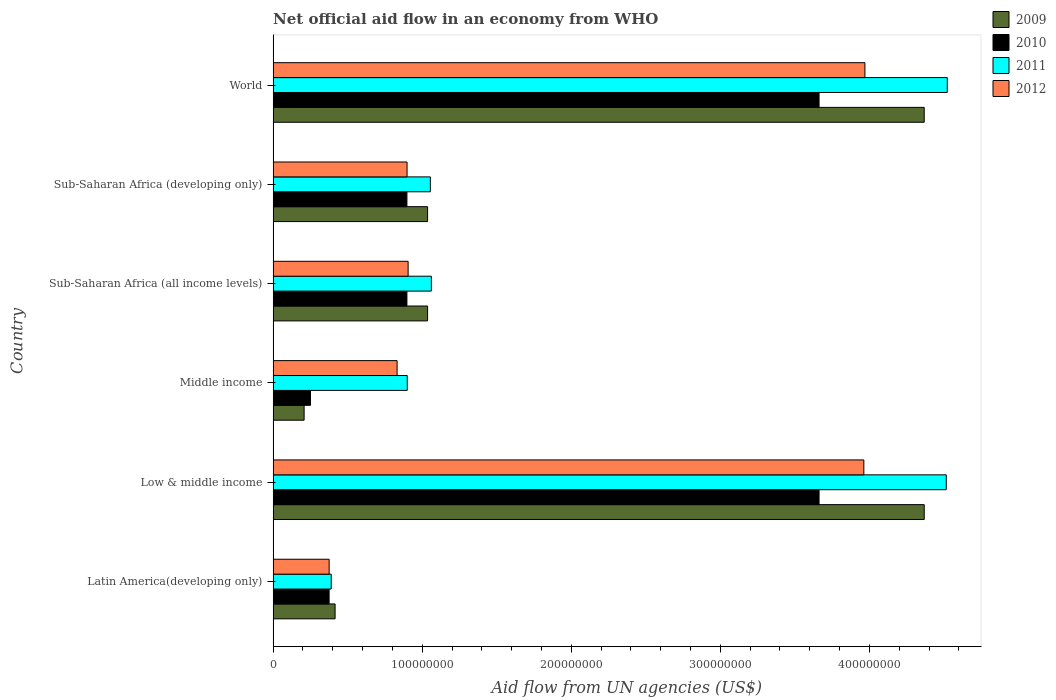How many different coloured bars are there?
Provide a succinct answer. 4. How many groups of bars are there?
Give a very brief answer. 6. Are the number of bars per tick equal to the number of legend labels?
Your answer should be very brief. Yes. How many bars are there on the 1st tick from the bottom?
Make the answer very short. 4. What is the label of the 1st group of bars from the top?
Provide a short and direct response. World. What is the net official aid flow in 2012 in Sub-Saharan Africa (developing only)?
Provide a short and direct response. 8.98e+07. Across all countries, what is the maximum net official aid flow in 2012?
Keep it short and to the point. 3.97e+08. Across all countries, what is the minimum net official aid flow in 2009?
Offer a terse response. 2.08e+07. What is the total net official aid flow in 2009 in the graph?
Your answer should be very brief. 1.14e+09. What is the difference between the net official aid flow in 2012 in Latin America(developing only) and that in Low & middle income?
Your answer should be very brief. -3.59e+08. What is the difference between the net official aid flow in 2011 in Sub-Saharan Africa (all income levels) and the net official aid flow in 2009 in Middle income?
Give a very brief answer. 8.54e+07. What is the average net official aid flow in 2009 per country?
Give a very brief answer. 1.91e+08. What is the difference between the net official aid flow in 2012 and net official aid flow in 2009 in Middle income?
Your answer should be very brief. 6.24e+07. In how many countries, is the net official aid flow in 2011 greater than 300000000 US$?
Offer a terse response. 2. What is the ratio of the net official aid flow in 2009 in Low & middle income to that in Sub-Saharan Africa (developing only)?
Your answer should be compact. 4.22. What is the difference between the highest and the second highest net official aid flow in 2011?
Your response must be concise. 6.70e+05. What is the difference between the highest and the lowest net official aid flow in 2010?
Make the answer very short. 3.41e+08. In how many countries, is the net official aid flow in 2012 greater than the average net official aid flow in 2012 taken over all countries?
Provide a succinct answer. 2. Is the sum of the net official aid flow in 2010 in Low & middle income and Sub-Saharan Africa (all income levels) greater than the maximum net official aid flow in 2012 across all countries?
Provide a short and direct response. Yes. Is it the case that in every country, the sum of the net official aid flow in 2010 and net official aid flow in 2009 is greater than the sum of net official aid flow in 2012 and net official aid flow in 2011?
Your answer should be very brief. No. What does the 4th bar from the top in Middle income represents?
Keep it short and to the point. 2009. Is it the case that in every country, the sum of the net official aid flow in 2010 and net official aid flow in 2009 is greater than the net official aid flow in 2012?
Your answer should be compact. No. How many bars are there?
Your answer should be compact. 24. Are all the bars in the graph horizontal?
Provide a short and direct response. Yes. What is the difference between two consecutive major ticks on the X-axis?
Your answer should be very brief. 1.00e+08. Are the values on the major ticks of X-axis written in scientific E-notation?
Offer a terse response. No. Does the graph contain grids?
Your answer should be very brief. No. What is the title of the graph?
Offer a very short reply. Net official aid flow in an economy from WHO. Does "1975" appear as one of the legend labels in the graph?
Offer a very short reply. No. What is the label or title of the X-axis?
Your response must be concise. Aid flow from UN agencies (US$). What is the label or title of the Y-axis?
Provide a short and direct response. Country. What is the Aid flow from UN agencies (US$) in 2009 in Latin America(developing only)?
Your response must be concise. 4.16e+07. What is the Aid flow from UN agencies (US$) of 2010 in Latin America(developing only)?
Provide a short and direct response. 3.76e+07. What is the Aid flow from UN agencies (US$) in 2011 in Latin America(developing only)?
Make the answer very short. 3.90e+07. What is the Aid flow from UN agencies (US$) in 2012 in Latin America(developing only)?
Provide a succinct answer. 3.76e+07. What is the Aid flow from UN agencies (US$) in 2009 in Low & middle income?
Make the answer very short. 4.37e+08. What is the Aid flow from UN agencies (US$) in 2010 in Low & middle income?
Your answer should be compact. 3.66e+08. What is the Aid flow from UN agencies (US$) of 2011 in Low & middle income?
Ensure brevity in your answer.  4.52e+08. What is the Aid flow from UN agencies (US$) in 2012 in Low & middle income?
Your answer should be very brief. 3.96e+08. What is the Aid flow from UN agencies (US$) in 2009 in Middle income?
Give a very brief answer. 2.08e+07. What is the Aid flow from UN agencies (US$) of 2010 in Middle income?
Offer a very short reply. 2.51e+07. What is the Aid flow from UN agencies (US$) of 2011 in Middle income?
Your answer should be compact. 9.00e+07. What is the Aid flow from UN agencies (US$) in 2012 in Middle income?
Provide a short and direct response. 8.32e+07. What is the Aid flow from UN agencies (US$) in 2009 in Sub-Saharan Africa (all income levels)?
Offer a terse response. 1.04e+08. What is the Aid flow from UN agencies (US$) of 2010 in Sub-Saharan Africa (all income levels)?
Offer a very short reply. 8.98e+07. What is the Aid flow from UN agencies (US$) in 2011 in Sub-Saharan Africa (all income levels)?
Ensure brevity in your answer.  1.06e+08. What is the Aid flow from UN agencies (US$) in 2012 in Sub-Saharan Africa (all income levels)?
Provide a short and direct response. 9.06e+07. What is the Aid flow from UN agencies (US$) of 2009 in Sub-Saharan Africa (developing only)?
Make the answer very short. 1.04e+08. What is the Aid flow from UN agencies (US$) in 2010 in Sub-Saharan Africa (developing only)?
Give a very brief answer. 8.98e+07. What is the Aid flow from UN agencies (US$) in 2011 in Sub-Saharan Africa (developing only)?
Keep it short and to the point. 1.05e+08. What is the Aid flow from UN agencies (US$) of 2012 in Sub-Saharan Africa (developing only)?
Offer a terse response. 8.98e+07. What is the Aid flow from UN agencies (US$) of 2009 in World?
Your response must be concise. 4.37e+08. What is the Aid flow from UN agencies (US$) in 2010 in World?
Your answer should be very brief. 3.66e+08. What is the Aid flow from UN agencies (US$) of 2011 in World?
Your response must be concise. 4.52e+08. What is the Aid flow from UN agencies (US$) in 2012 in World?
Keep it short and to the point. 3.97e+08. Across all countries, what is the maximum Aid flow from UN agencies (US$) of 2009?
Make the answer very short. 4.37e+08. Across all countries, what is the maximum Aid flow from UN agencies (US$) in 2010?
Make the answer very short. 3.66e+08. Across all countries, what is the maximum Aid flow from UN agencies (US$) of 2011?
Make the answer very short. 4.52e+08. Across all countries, what is the maximum Aid flow from UN agencies (US$) of 2012?
Offer a terse response. 3.97e+08. Across all countries, what is the minimum Aid flow from UN agencies (US$) in 2009?
Offer a very short reply. 2.08e+07. Across all countries, what is the minimum Aid flow from UN agencies (US$) in 2010?
Provide a short and direct response. 2.51e+07. Across all countries, what is the minimum Aid flow from UN agencies (US$) in 2011?
Offer a terse response. 3.90e+07. Across all countries, what is the minimum Aid flow from UN agencies (US$) of 2012?
Make the answer very short. 3.76e+07. What is the total Aid flow from UN agencies (US$) in 2009 in the graph?
Keep it short and to the point. 1.14e+09. What is the total Aid flow from UN agencies (US$) in 2010 in the graph?
Provide a short and direct response. 9.75e+08. What is the total Aid flow from UN agencies (US$) in 2011 in the graph?
Offer a terse response. 1.24e+09. What is the total Aid flow from UN agencies (US$) of 2012 in the graph?
Your response must be concise. 1.09e+09. What is the difference between the Aid flow from UN agencies (US$) of 2009 in Latin America(developing only) and that in Low & middle income?
Your answer should be compact. -3.95e+08. What is the difference between the Aid flow from UN agencies (US$) in 2010 in Latin America(developing only) and that in Low & middle income?
Provide a short and direct response. -3.29e+08. What is the difference between the Aid flow from UN agencies (US$) of 2011 in Latin America(developing only) and that in Low & middle income?
Provide a succinct answer. -4.13e+08. What is the difference between the Aid flow from UN agencies (US$) of 2012 in Latin America(developing only) and that in Low & middle income?
Your answer should be compact. -3.59e+08. What is the difference between the Aid flow from UN agencies (US$) of 2009 in Latin America(developing only) and that in Middle income?
Provide a short and direct response. 2.08e+07. What is the difference between the Aid flow from UN agencies (US$) in 2010 in Latin America(developing only) and that in Middle income?
Give a very brief answer. 1.25e+07. What is the difference between the Aid flow from UN agencies (US$) in 2011 in Latin America(developing only) and that in Middle income?
Give a very brief answer. -5.10e+07. What is the difference between the Aid flow from UN agencies (US$) of 2012 in Latin America(developing only) and that in Middle income?
Keep it short and to the point. -4.56e+07. What is the difference between the Aid flow from UN agencies (US$) of 2009 in Latin America(developing only) and that in Sub-Saharan Africa (all income levels)?
Your answer should be very brief. -6.20e+07. What is the difference between the Aid flow from UN agencies (US$) in 2010 in Latin America(developing only) and that in Sub-Saharan Africa (all income levels)?
Provide a succinct answer. -5.22e+07. What is the difference between the Aid flow from UN agencies (US$) in 2011 in Latin America(developing only) and that in Sub-Saharan Africa (all income levels)?
Offer a very short reply. -6.72e+07. What is the difference between the Aid flow from UN agencies (US$) of 2012 in Latin America(developing only) and that in Sub-Saharan Africa (all income levels)?
Ensure brevity in your answer.  -5.30e+07. What is the difference between the Aid flow from UN agencies (US$) of 2009 in Latin America(developing only) and that in Sub-Saharan Africa (developing only)?
Your response must be concise. -6.20e+07. What is the difference between the Aid flow from UN agencies (US$) in 2010 in Latin America(developing only) and that in Sub-Saharan Africa (developing only)?
Provide a short and direct response. -5.22e+07. What is the difference between the Aid flow from UN agencies (US$) of 2011 in Latin America(developing only) and that in Sub-Saharan Africa (developing only)?
Provide a short and direct response. -6.65e+07. What is the difference between the Aid flow from UN agencies (US$) in 2012 in Latin America(developing only) and that in Sub-Saharan Africa (developing only)?
Keep it short and to the point. -5.23e+07. What is the difference between the Aid flow from UN agencies (US$) in 2009 in Latin America(developing only) and that in World?
Keep it short and to the point. -3.95e+08. What is the difference between the Aid flow from UN agencies (US$) of 2010 in Latin America(developing only) and that in World?
Your answer should be very brief. -3.29e+08. What is the difference between the Aid flow from UN agencies (US$) in 2011 in Latin America(developing only) and that in World?
Offer a terse response. -4.13e+08. What is the difference between the Aid flow from UN agencies (US$) of 2012 in Latin America(developing only) and that in World?
Keep it short and to the point. -3.59e+08. What is the difference between the Aid flow from UN agencies (US$) of 2009 in Low & middle income and that in Middle income?
Make the answer very short. 4.16e+08. What is the difference between the Aid flow from UN agencies (US$) of 2010 in Low & middle income and that in Middle income?
Provide a succinct answer. 3.41e+08. What is the difference between the Aid flow from UN agencies (US$) in 2011 in Low & middle income and that in Middle income?
Offer a terse response. 3.62e+08. What is the difference between the Aid flow from UN agencies (US$) of 2012 in Low & middle income and that in Middle income?
Your response must be concise. 3.13e+08. What is the difference between the Aid flow from UN agencies (US$) of 2009 in Low & middle income and that in Sub-Saharan Africa (all income levels)?
Give a very brief answer. 3.33e+08. What is the difference between the Aid flow from UN agencies (US$) of 2010 in Low & middle income and that in Sub-Saharan Africa (all income levels)?
Offer a terse response. 2.76e+08. What is the difference between the Aid flow from UN agencies (US$) in 2011 in Low & middle income and that in Sub-Saharan Africa (all income levels)?
Keep it short and to the point. 3.45e+08. What is the difference between the Aid flow from UN agencies (US$) of 2012 in Low & middle income and that in Sub-Saharan Africa (all income levels)?
Your response must be concise. 3.06e+08. What is the difference between the Aid flow from UN agencies (US$) in 2009 in Low & middle income and that in Sub-Saharan Africa (developing only)?
Your answer should be compact. 3.33e+08. What is the difference between the Aid flow from UN agencies (US$) of 2010 in Low & middle income and that in Sub-Saharan Africa (developing only)?
Provide a short and direct response. 2.76e+08. What is the difference between the Aid flow from UN agencies (US$) in 2011 in Low & middle income and that in Sub-Saharan Africa (developing only)?
Offer a very short reply. 3.46e+08. What is the difference between the Aid flow from UN agencies (US$) of 2012 in Low & middle income and that in Sub-Saharan Africa (developing only)?
Make the answer very short. 3.06e+08. What is the difference between the Aid flow from UN agencies (US$) in 2009 in Low & middle income and that in World?
Offer a very short reply. 0. What is the difference between the Aid flow from UN agencies (US$) in 2010 in Low & middle income and that in World?
Keep it short and to the point. 0. What is the difference between the Aid flow from UN agencies (US$) in 2011 in Low & middle income and that in World?
Ensure brevity in your answer.  -6.70e+05. What is the difference between the Aid flow from UN agencies (US$) in 2012 in Low & middle income and that in World?
Your answer should be compact. -7.20e+05. What is the difference between the Aid flow from UN agencies (US$) of 2009 in Middle income and that in Sub-Saharan Africa (all income levels)?
Keep it short and to the point. -8.28e+07. What is the difference between the Aid flow from UN agencies (US$) in 2010 in Middle income and that in Sub-Saharan Africa (all income levels)?
Make the answer very short. -6.47e+07. What is the difference between the Aid flow from UN agencies (US$) in 2011 in Middle income and that in Sub-Saharan Africa (all income levels)?
Offer a very short reply. -1.62e+07. What is the difference between the Aid flow from UN agencies (US$) in 2012 in Middle income and that in Sub-Saharan Africa (all income levels)?
Your answer should be compact. -7.39e+06. What is the difference between the Aid flow from UN agencies (US$) of 2009 in Middle income and that in Sub-Saharan Africa (developing only)?
Ensure brevity in your answer.  -8.28e+07. What is the difference between the Aid flow from UN agencies (US$) in 2010 in Middle income and that in Sub-Saharan Africa (developing only)?
Keep it short and to the point. -6.47e+07. What is the difference between the Aid flow from UN agencies (US$) in 2011 in Middle income and that in Sub-Saharan Africa (developing only)?
Give a very brief answer. -1.55e+07. What is the difference between the Aid flow from UN agencies (US$) in 2012 in Middle income and that in Sub-Saharan Africa (developing only)?
Provide a short and direct response. -6.67e+06. What is the difference between the Aid flow from UN agencies (US$) of 2009 in Middle income and that in World?
Make the answer very short. -4.16e+08. What is the difference between the Aid flow from UN agencies (US$) in 2010 in Middle income and that in World?
Make the answer very short. -3.41e+08. What is the difference between the Aid flow from UN agencies (US$) in 2011 in Middle income and that in World?
Your answer should be very brief. -3.62e+08. What is the difference between the Aid flow from UN agencies (US$) of 2012 in Middle income and that in World?
Provide a short and direct response. -3.14e+08. What is the difference between the Aid flow from UN agencies (US$) in 2010 in Sub-Saharan Africa (all income levels) and that in Sub-Saharan Africa (developing only)?
Your answer should be compact. 0. What is the difference between the Aid flow from UN agencies (US$) of 2011 in Sub-Saharan Africa (all income levels) and that in Sub-Saharan Africa (developing only)?
Your response must be concise. 6.70e+05. What is the difference between the Aid flow from UN agencies (US$) in 2012 in Sub-Saharan Africa (all income levels) and that in Sub-Saharan Africa (developing only)?
Provide a short and direct response. 7.20e+05. What is the difference between the Aid flow from UN agencies (US$) in 2009 in Sub-Saharan Africa (all income levels) and that in World?
Make the answer very short. -3.33e+08. What is the difference between the Aid flow from UN agencies (US$) in 2010 in Sub-Saharan Africa (all income levels) and that in World?
Give a very brief answer. -2.76e+08. What is the difference between the Aid flow from UN agencies (US$) of 2011 in Sub-Saharan Africa (all income levels) and that in World?
Offer a terse response. -3.46e+08. What is the difference between the Aid flow from UN agencies (US$) in 2012 in Sub-Saharan Africa (all income levels) and that in World?
Your answer should be very brief. -3.06e+08. What is the difference between the Aid flow from UN agencies (US$) of 2009 in Sub-Saharan Africa (developing only) and that in World?
Your answer should be compact. -3.33e+08. What is the difference between the Aid flow from UN agencies (US$) in 2010 in Sub-Saharan Africa (developing only) and that in World?
Your response must be concise. -2.76e+08. What is the difference between the Aid flow from UN agencies (US$) in 2011 in Sub-Saharan Africa (developing only) and that in World?
Offer a terse response. -3.47e+08. What is the difference between the Aid flow from UN agencies (US$) of 2012 in Sub-Saharan Africa (developing only) and that in World?
Provide a succinct answer. -3.07e+08. What is the difference between the Aid flow from UN agencies (US$) in 2009 in Latin America(developing only) and the Aid flow from UN agencies (US$) in 2010 in Low & middle income?
Ensure brevity in your answer.  -3.25e+08. What is the difference between the Aid flow from UN agencies (US$) of 2009 in Latin America(developing only) and the Aid flow from UN agencies (US$) of 2011 in Low & middle income?
Ensure brevity in your answer.  -4.10e+08. What is the difference between the Aid flow from UN agencies (US$) in 2009 in Latin America(developing only) and the Aid flow from UN agencies (US$) in 2012 in Low & middle income?
Give a very brief answer. -3.55e+08. What is the difference between the Aid flow from UN agencies (US$) of 2010 in Latin America(developing only) and the Aid flow from UN agencies (US$) of 2011 in Low & middle income?
Make the answer very short. -4.14e+08. What is the difference between the Aid flow from UN agencies (US$) of 2010 in Latin America(developing only) and the Aid flow from UN agencies (US$) of 2012 in Low & middle income?
Your answer should be very brief. -3.59e+08. What is the difference between the Aid flow from UN agencies (US$) of 2011 in Latin America(developing only) and the Aid flow from UN agencies (US$) of 2012 in Low & middle income?
Provide a short and direct response. -3.57e+08. What is the difference between the Aid flow from UN agencies (US$) of 2009 in Latin America(developing only) and the Aid flow from UN agencies (US$) of 2010 in Middle income?
Offer a very short reply. 1.65e+07. What is the difference between the Aid flow from UN agencies (US$) of 2009 in Latin America(developing only) and the Aid flow from UN agencies (US$) of 2011 in Middle income?
Offer a very short reply. -4.84e+07. What is the difference between the Aid flow from UN agencies (US$) in 2009 in Latin America(developing only) and the Aid flow from UN agencies (US$) in 2012 in Middle income?
Offer a very short reply. -4.16e+07. What is the difference between the Aid flow from UN agencies (US$) in 2010 in Latin America(developing only) and the Aid flow from UN agencies (US$) in 2011 in Middle income?
Provide a short and direct response. -5.24e+07. What is the difference between the Aid flow from UN agencies (US$) of 2010 in Latin America(developing only) and the Aid flow from UN agencies (US$) of 2012 in Middle income?
Provide a short and direct response. -4.56e+07. What is the difference between the Aid flow from UN agencies (US$) of 2011 in Latin America(developing only) and the Aid flow from UN agencies (US$) of 2012 in Middle income?
Your answer should be very brief. -4.42e+07. What is the difference between the Aid flow from UN agencies (US$) of 2009 in Latin America(developing only) and the Aid flow from UN agencies (US$) of 2010 in Sub-Saharan Africa (all income levels)?
Ensure brevity in your answer.  -4.82e+07. What is the difference between the Aid flow from UN agencies (US$) in 2009 in Latin America(developing only) and the Aid flow from UN agencies (US$) in 2011 in Sub-Saharan Africa (all income levels)?
Your response must be concise. -6.46e+07. What is the difference between the Aid flow from UN agencies (US$) of 2009 in Latin America(developing only) and the Aid flow from UN agencies (US$) of 2012 in Sub-Saharan Africa (all income levels)?
Your response must be concise. -4.90e+07. What is the difference between the Aid flow from UN agencies (US$) in 2010 in Latin America(developing only) and the Aid flow from UN agencies (US$) in 2011 in Sub-Saharan Africa (all income levels)?
Your answer should be compact. -6.86e+07. What is the difference between the Aid flow from UN agencies (US$) in 2010 in Latin America(developing only) and the Aid flow from UN agencies (US$) in 2012 in Sub-Saharan Africa (all income levels)?
Provide a succinct answer. -5.30e+07. What is the difference between the Aid flow from UN agencies (US$) of 2011 in Latin America(developing only) and the Aid flow from UN agencies (US$) of 2012 in Sub-Saharan Africa (all income levels)?
Offer a terse response. -5.16e+07. What is the difference between the Aid flow from UN agencies (US$) of 2009 in Latin America(developing only) and the Aid flow from UN agencies (US$) of 2010 in Sub-Saharan Africa (developing only)?
Your response must be concise. -4.82e+07. What is the difference between the Aid flow from UN agencies (US$) in 2009 in Latin America(developing only) and the Aid flow from UN agencies (US$) in 2011 in Sub-Saharan Africa (developing only)?
Provide a succinct answer. -6.39e+07. What is the difference between the Aid flow from UN agencies (US$) of 2009 in Latin America(developing only) and the Aid flow from UN agencies (US$) of 2012 in Sub-Saharan Africa (developing only)?
Keep it short and to the point. -4.83e+07. What is the difference between the Aid flow from UN agencies (US$) of 2010 in Latin America(developing only) and the Aid flow from UN agencies (US$) of 2011 in Sub-Saharan Africa (developing only)?
Offer a very short reply. -6.79e+07. What is the difference between the Aid flow from UN agencies (US$) of 2010 in Latin America(developing only) and the Aid flow from UN agencies (US$) of 2012 in Sub-Saharan Africa (developing only)?
Your answer should be very brief. -5.23e+07. What is the difference between the Aid flow from UN agencies (US$) in 2011 in Latin America(developing only) and the Aid flow from UN agencies (US$) in 2012 in Sub-Saharan Africa (developing only)?
Offer a terse response. -5.09e+07. What is the difference between the Aid flow from UN agencies (US$) of 2009 in Latin America(developing only) and the Aid flow from UN agencies (US$) of 2010 in World?
Offer a terse response. -3.25e+08. What is the difference between the Aid flow from UN agencies (US$) of 2009 in Latin America(developing only) and the Aid flow from UN agencies (US$) of 2011 in World?
Provide a succinct answer. -4.11e+08. What is the difference between the Aid flow from UN agencies (US$) of 2009 in Latin America(developing only) and the Aid flow from UN agencies (US$) of 2012 in World?
Your answer should be compact. -3.55e+08. What is the difference between the Aid flow from UN agencies (US$) in 2010 in Latin America(developing only) and the Aid flow from UN agencies (US$) in 2011 in World?
Your answer should be compact. -4.15e+08. What is the difference between the Aid flow from UN agencies (US$) of 2010 in Latin America(developing only) and the Aid flow from UN agencies (US$) of 2012 in World?
Give a very brief answer. -3.59e+08. What is the difference between the Aid flow from UN agencies (US$) of 2011 in Latin America(developing only) and the Aid flow from UN agencies (US$) of 2012 in World?
Give a very brief answer. -3.58e+08. What is the difference between the Aid flow from UN agencies (US$) in 2009 in Low & middle income and the Aid flow from UN agencies (US$) in 2010 in Middle income?
Make the answer very short. 4.12e+08. What is the difference between the Aid flow from UN agencies (US$) of 2009 in Low & middle income and the Aid flow from UN agencies (US$) of 2011 in Middle income?
Make the answer very short. 3.47e+08. What is the difference between the Aid flow from UN agencies (US$) of 2009 in Low & middle income and the Aid flow from UN agencies (US$) of 2012 in Middle income?
Provide a succinct answer. 3.54e+08. What is the difference between the Aid flow from UN agencies (US$) in 2010 in Low & middle income and the Aid flow from UN agencies (US$) in 2011 in Middle income?
Offer a very short reply. 2.76e+08. What is the difference between the Aid flow from UN agencies (US$) in 2010 in Low & middle income and the Aid flow from UN agencies (US$) in 2012 in Middle income?
Give a very brief answer. 2.83e+08. What is the difference between the Aid flow from UN agencies (US$) of 2011 in Low & middle income and the Aid flow from UN agencies (US$) of 2012 in Middle income?
Keep it short and to the point. 3.68e+08. What is the difference between the Aid flow from UN agencies (US$) of 2009 in Low & middle income and the Aid flow from UN agencies (US$) of 2010 in Sub-Saharan Africa (all income levels)?
Keep it short and to the point. 3.47e+08. What is the difference between the Aid flow from UN agencies (US$) of 2009 in Low & middle income and the Aid flow from UN agencies (US$) of 2011 in Sub-Saharan Africa (all income levels)?
Give a very brief answer. 3.31e+08. What is the difference between the Aid flow from UN agencies (US$) of 2009 in Low & middle income and the Aid flow from UN agencies (US$) of 2012 in Sub-Saharan Africa (all income levels)?
Your answer should be compact. 3.46e+08. What is the difference between the Aid flow from UN agencies (US$) of 2010 in Low & middle income and the Aid flow from UN agencies (US$) of 2011 in Sub-Saharan Africa (all income levels)?
Ensure brevity in your answer.  2.60e+08. What is the difference between the Aid flow from UN agencies (US$) in 2010 in Low & middle income and the Aid flow from UN agencies (US$) in 2012 in Sub-Saharan Africa (all income levels)?
Offer a very short reply. 2.76e+08. What is the difference between the Aid flow from UN agencies (US$) in 2011 in Low & middle income and the Aid flow from UN agencies (US$) in 2012 in Sub-Saharan Africa (all income levels)?
Keep it short and to the point. 3.61e+08. What is the difference between the Aid flow from UN agencies (US$) of 2009 in Low & middle income and the Aid flow from UN agencies (US$) of 2010 in Sub-Saharan Africa (developing only)?
Give a very brief answer. 3.47e+08. What is the difference between the Aid flow from UN agencies (US$) of 2009 in Low & middle income and the Aid flow from UN agencies (US$) of 2011 in Sub-Saharan Africa (developing only)?
Your answer should be compact. 3.31e+08. What is the difference between the Aid flow from UN agencies (US$) of 2009 in Low & middle income and the Aid flow from UN agencies (US$) of 2012 in Sub-Saharan Africa (developing only)?
Your answer should be compact. 3.47e+08. What is the difference between the Aid flow from UN agencies (US$) of 2010 in Low & middle income and the Aid flow from UN agencies (US$) of 2011 in Sub-Saharan Africa (developing only)?
Give a very brief answer. 2.61e+08. What is the difference between the Aid flow from UN agencies (US$) in 2010 in Low & middle income and the Aid flow from UN agencies (US$) in 2012 in Sub-Saharan Africa (developing only)?
Make the answer very short. 2.76e+08. What is the difference between the Aid flow from UN agencies (US$) of 2011 in Low & middle income and the Aid flow from UN agencies (US$) of 2012 in Sub-Saharan Africa (developing only)?
Keep it short and to the point. 3.62e+08. What is the difference between the Aid flow from UN agencies (US$) in 2009 in Low & middle income and the Aid flow from UN agencies (US$) in 2010 in World?
Provide a succinct answer. 7.06e+07. What is the difference between the Aid flow from UN agencies (US$) of 2009 in Low & middle income and the Aid flow from UN agencies (US$) of 2011 in World?
Your answer should be very brief. -1.55e+07. What is the difference between the Aid flow from UN agencies (US$) in 2009 in Low & middle income and the Aid flow from UN agencies (US$) in 2012 in World?
Give a very brief answer. 3.98e+07. What is the difference between the Aid flow from UN agencies (US$) in 2010 in Low & middle income and the Aid flow from UN agencies (US$) in 2011 in World?
Your response must be concise. -8.60e+07. What is the difference between the Aid flow from UN agencies (US$) of 2010 in Low & middle income and the Aid flow from UN agencies (US$) of 2012 in World?
Give a very brief answer. -3.08e+07. What is the difference between the Aid flow from UN agencies (US$) of 2011 in Low & middle income and the Aid flow from UN agencies (US$) of 2012 in World?
Provide a succinct answer. 5.46e+07. What is the difference between the Aid flow from UN agencies (US$) of 2009 in Middle income and the Aid flow from UN agencies (US$) of 2010 in Sub-Saharan Africa (all income levels)?
Your answer should be compact. -6.90e+07. What is the difference between the Aid flow from UN agencies (US$) of 2009 in Middle income and the Aid flow from UN agencies (US$) of 2011 in Sub-Saharan Africa (all income levels)?
Your answer should be compact. -8.54e+07. What is the difference between the Aid flow from UN agencies (US$) of 2009 in Middle income and the Aid flow from UN agencies (US$) of 2012 in Sub-Saharan Africa (all income levels)?
Give a very brief answer. -6.98e+07. What is the difference between the Aid flow from UN agencies (US$) in 2010 in Middle income and the Aid flow from UN agencies (US$) in 2011 in Sub-Saharan Africa (all income levels)?
Give a very brief answer. -8.11e+07. What is the difference between the Aid flow from UN agencies (US$) in 2010 in Middle income and the Aid flow from UN agencies (US$) in 2012 in Sub-Saharan Africa (all income levels)?
Provide a succinct answer. -6.55e+07. What is the difference between the Aid flow from UN agencies (US$) in 2011 in Middle income and the Aid flow from UN agencies (US$) in 2012 in Sub-Saharan Africa (all income levels)?
Make the answer very short. -5.90e+05. What is the difference between the Aid flow from UN agencies (US$) of 2009 in Middle income and the Aid flow from UN agencies (US$) of 2010 in Sub-Saharan Africa (developing only)?
Your answer should be very brief. -6.90e+07. What is the difference between the Aid flow from UN agencies (US$) of 2009 in Middle income and the Aid flow from UN agencies (US$) of 2011 in Sub-Saharan Africa (developing only)?
Keep it short and to the point. -8.47e+07. What is the difference between the Aid flow from UN agencies (US$) in 2009 in Middle income and the Aid flow from UN agencies (US$) in 2012 in Sub-Saharan Africa (developing only)?
Make the answer very short. -6.90e+07. What is the difference between the Aid flow from UN agencies (US$) in 2010 in Middle income and the Aid flow from UN agencies (US$) in 2011 in Sub-Saharan Africa (developing only)?
Provide a succinct answer. -8.04e+07. What is the difference between the Aid flow from UN agencies (US$) in 2010 in Middle income and the Aid flow from UN agencies (US$) in 2012 in Sub-Saharan Africa (developing only)?
Offer a terse response. -6.48e+07. What is the difference between the Aid flow from UN agencies (US$) in 2009 in Middle income and the Aid flow from UN agencies (US$) in 2010 in World?
Make the answer very short. -3.45e+08. What is the difference between the Aid flow from UN agencies (US$) of 2009 in Middle income and the Aid flow from UN agencies (US$) of 2011 in World?
Give a very brief answer. -4.31e+08. What is the difference between the Aid flow from UN agencies (US$) of 2009 in Middle income and the Aid flow from UN agencies (US$) of 2012 in World?
Keep it short and to the point. -3.76e+08. What is the difference between the Aid flow from UN agencies (US$) in 2010 in Middle income and the Aid flow from UN agencies (US$) in 2011 in World?
Your answer should be very brief. -4.27e+08. What is the difference between the Aid flow from UN agencies (US$) of 2010 in Middle income and the Aid flow from UN agencies (US$) of 2012 in World?
Ensure brevity in your answer.  -3.72e+08. What is the difference between the Aid flow from UN agencies (US$) in 2011 in Middle income and the Aid flow from UN agencies (US$) in 2012 in World?
Offer a terse response. -3.07e+08. What is the difference between the Aid flow from UN agencies (US$) of 2009 in Sub-Saharan Africa (all income levels) and the Aid flow from UN agencies (US$) of 2010 in Sub-Saharan Africa (developing only)?
Provide a short and direct response. 1.39e+07. What is the difference between the Aid flow from UN agencies (US$) in 2009 in Sub-Saharan Africa (all income levels) and the Aid flow from UN agencies (US$) in 2011 in Sub-Saharan Africa (developing only)?
Keep it short and to the point. -1.86e+06. What is the difference between the Aid flow from UN agencies (US$) in 2009 in Sub-Saharan Africa (all income levels) and the Aid flow from UN agencies (US$) in 2012 in Sub-Saharan Africa (developing only)?
Your answer should be compact. 1.38e+07. What is the difference between the Aid flow from UN agencies (US$) of 2010 in Sub-Saharan Africa (all income levels) and the Aid flow from UN agencies (US$) of 2011 in Sub-Saharan Africa (developing only)?
Give a very brief answer. -1.57e+07. What is the difference between the Aid flow from UN agencies (US$) in 2011 in Sub-Saharan Africa (all income levels) and the Aid flow from UN agencies (US$) in 2012 in Sub-Saharan Africa (developing only)?
Ensure brevity in your answer.  1.63e+07. What is the difference between the Aid flow from UN agencies (US$) in 2009 in Sub-Saharan Africa (all income levels) and the Aid flow from UN agencies (US$) in 2010 in World?
Make the answer very short. -2.63e+08. What is the difference between the Aid flow from UN agencies (US$) of 2009 in Sub-Saharan Africa (all income levels) and the Aid flow from UN agencies (US$) of 2011 in World?
Provide a short and direct response. -3.49e+08. What is the difference between the Aid flow from UN agencies (US$) in 2009 in Sub-Saharan Africa (all income levels) and the Aid flow from UN agencies (US$) in 2012 in World?
Provide a short and direct response. -2.93e+08. What is the difference between the Aid flow from UN agencies (US$) of 2010 in Sub-Saharan Africa (all income levels) and the Aid flow from UN agencies (US$) of 2011 in World?
Give a very brief answer. -3.62e+08. What is the difference between the Aid flow from UN agencies (US$) in 2010 in Sub-Saharan Africa (all income levels) and the Aid flow from UN agencies (US$) in 2012 in World?
Your answer should be very brief. -3.07e+08. What is the difference between the Aid flow from UN agencies (US$) in 2011 in Sub-Saharan Africa (all income levels) and the Aid flow from UN agencies (US$) in 2012 in World?
Provide a short and direct response. -2.91e+08. What is the difference between the Aid flow from UN agencies (US$) of 2009 in Sub-Saharan Africa (developing only) and the Aid flow from UN agencies (US$) of 2010 in World?
Give a very brief answer. -2.63e+08. What is the difference between the Aid flow from UN agencies (US$) in 2009 in Sub-Saharan Africa (developing only) and the Aid flow from UN agencies (US$) in 2011 in World?
Your answer should be very brief. -3.49e+08. What is the difference between the Aid flow from UN agencies (US$) in 2009 in Sub-Saharan Africa (developing only) and the Aid flow from UN agencies (US$) in 2012 in World?
Give a very brief answer. -2.93e+08. What is the difference between the Aid flow from UN agencies (US$) of 2010 in Sub-Saharan Africa (developing only) and the Aid flow from UN agencies (US$) of 2011 in World?
Keep it short and to the point. -3.62e+08. What is the difference between the Aid flow from UN agencies (US$) of 2010 in Sub-Saharan Africa (developing only) and the Aid flow from UN agencies (US$) of 2012 in World?
Give a very brief answer. -3.07e+08. What is the difference between the Aid flow from UN agencies (US$) of 2011 in Sub-Saharan Africa (developing only) and the Aid flow from UN agencies (US$) of 2012 in World?
Make the answer very short. -2.92e+08. What is the average Aid flow from UN agencies (US$) in 2009 per country?
Your answer should be very brief. 1.91e+08. What is the average Aid flow from UN agencies (US$) in 2010 per country?
Make the answer very short. 1.62e+08. What is the average Aid flow from UN agencies (US$) in 2011 per country?
Provide a short and direct response. 2.07e+08. What is the average Aid flow from UN agencies (US$) in 2012 per country?
Ensure brevity in your answer.  1.82e+08. What is the difference between the Aid flow from UN agencies (US$) of 2009 and Aid flow from UN agencies (US$) of 2010 in Latin America(developing only)?
Offer a very short reply. 4.01e+06. What is the difference between the Aid flow from UN agencies (US$) of 2009 and Aid flow from UN agencies (US$) of 2011 in Latin America(developing only)?
Your response must be concise. 2.59e+06. What is the difference between the Aid flow from UN agencies (US$) in 2009 and Aid flow from UN agencies (US$) in 2012 in Latin America(developing only)?
Your answer should be compact. 3.99e+06. What is the difference between the Aid flow from UN agencies (US$) in 2010 and Aid flow from UN agencies (US$) in 2011 in Latin America(developing only)?
Give a very brief answer. -1.42e+06. What is the difference between the Aid flow from UN agencies (US$) of 2011 and Aid flow from UN agencies (US$) of 2012 in Latin America(developing only)?
Provide a succinct answer. 1.40e+06. What is the difference between the Aid flow from UN agencies (US$) in 2009 and Aid flow from UN agencies (US$) in 2010 in Low & middle income?
Offer a terse response. 7.06e+07. What is the difference between the Aid flow from UN agencies (US$) in 2009 and Aid flow from UN agencies (US$) in 2011 in Low & middle income?
Provide a short and direct response. -1.48e+07. What is the difference between the Aid flow from UN agencies (US$) of 2009 and Aid flow from UN agencies (US$) of 2012 in Low & middle income?
Make the answer very short. 4.05e+07. What is the difference between the Aid flow from UN agencies (US$) in 2010 and Aid flow from UN agencies (US$) in 2011 in Low & middle income?
Your answer should be compact. -8.54e+07. What is the difference between the Aid flow from UN agencies (US$) in 2010 and Aid flow from UN agencies (US$) in 2012 in Low & middle income?
Give a very brief answer. -3.00e+07. What is the difference between the Aid flow from UN agencies (US$) of 2011 and Aid flow from UN agencies (US$) of 2012 in Low & middle income?
Your answer should be compact. 5.53e+07. What is the difference between the Aid flow from UN agencies (US$) in 2009 and Aid flow from UN agencies (US$) in 2010 in Middle income?
Ensure brevity in your answer.  -4.27e+06. What is the difference between the Aid flow from UN agencies (US$) of 2009 and Aid flow from UN agencies (US$) of 2011 in Middle income?
Offer a very short reply. -6.92e+07. What is the difference between the Aid flow from UN agencies (US$) of 2009 and Aid flow from UN agencies (US$) of 2012 in Middle income?
Your response must be concise. -6.24e+07. What is the difference between the Aid flow from UN agencies (US$) of 2010 and Aid flow from UN agencies (US$) of 2011 in Middle income?
Provide a succinct answer. -6.49e+07. What is the difference between the Aid flow from UN agencies (US$) in 2010 and Aid flow from UN agencies (US$) in 2012 in Middle income?
Your response must be concise. -5.81e+07. What is the difference between the Aid flow from UN agencies (US$) of 2011 and Aid flow from UN agencies (US$) of 2012 in Middle income?
Your answer should be very brief. 6.80e+06. What is the difference between the Aid flow from UN agencies (US$) in 2009 and Aid flow from UN agencies (US$) in 2010 in Sub-Saharan Africa (all income levels)?
Ensure brevity in your answer.  1.39e+07. What is the difference between the Aid flow from UN agencies (US$) in 2009 and Aid flow from UN agencies (US$) in 2011 in Sub-Saharan Africa (all income levels)?
Give a very brief answer. -2.53e+06. What is the difference between the Aid flow from UN agencies (US$) of 2009 and Aid flow from UN agencies (US$) of 2012 in Sub-Saharan Africa (all income levels)?
Give a very brief answer. 1.30e+07. What is the difference between the Aid flow from UN agencies (US$) of 2010 and Aid flow from UN agencies (US$) of 2011 in Sub-Saharan Africa (all income levels)?
Make the answer very short. -1.64e+07. What is the difference between the Aid flow from UN agencies (US$) of 2010 and Aid flow from UN agencies (US$) of 2012 in Sub-Saharan Africa (all income levels)?
Your answer should be compact. -8.10e+05. What is the difference between the Aid flow from UN agencies (US$) in 2011 and Aid flow from UN agencies (US$) in 2012 in Sub-Saharan Africa (all income levels)?
Keep it short and to the point. 1.56e+07. What is the difference between the Aid flow from UN agencies (US$) in 2009 and Aid flow from UN agencies (US$) in 2010 in Sub-Saharan Africa (developing only)?
Your response must be concise. 1.39e+07. What is the difference between the Aid flow from UN agencies (US$) of 2009 and Aid flow from UN agencies (US$) of 2011 in Sub-Saharan Africa (developing only)?
Offer a terse response. -1.86e+06. What is the difference between the Aid flow from UN agencies (US$) in 2009 and Aid flow from UN agencies (US$) in 2012 in Sub-Saharan Africa (developing only)?
Provide a short and direct response. 1.38e+07. What is the difference between the Aid flow from UN agencies (US$) in 2010 and Aid flow from UN agencies (US$) in 2011 in Sub-Saharan Africa (developing only)?
Your answer should be very brief. -1.57e+07. What is the difference between the Aid flow from UN agencies (US$) of 2011 and Aid flow from UN agencies (US$) of 2012 in Sub-Saharan Africa (developing only)?
Offer a terse response. 1.56e+07. What is the difference between the Aid flow from UN agencies (US$) in 2009 and Aid flow from UN agencies (US$) in 2010 in World?
Ensure brevity in your answer.  7.06e+07. What is the difference between the Aid flow from UN agencies (US$) in 2009 and Aid flow from UN agencies (US$) in 2011 in World?
Ensure brevity in your answer.  -1.55e+07. What is the difference between the Aid flow from UN agencies (US$) in 2009 and Aid flow from UN agencies (US$) in 2012 in World?
Your response must be concise. 3.98e+07. What is the difference between the Aid flow from UN agencies (US$) in 2010 and Aid flow from UN agencies (US$) in 2011 in World?
Make the answer very short. -8.60e+07. What is the difference between the Aid flow from UN agencies (US$) of 2010 and Aid flow from UN agencies (US$) of 2012 in World?
Keep it short and to the point. -3.08e+07. What is the difference between the Aid flow from UN agencies (US$) in 2011 and Aid flow from UN agencies (US$) in 2012 in World?
Your answer should be very brief. 5.53e+07. What is the ratio of the Aid flow from UN agencies (US$) in 2009 in Latin America(developing only) to that in Low & middle income?
Your answer should be compact. 0.1. What is the ratio of the Aid flow from UN agencies (US$) of 2010 in Latin America(developing only) to that in Low & middle income?
Your answer should be very brief. 0.1. What is the ratio of the Aid flow from UN agencies (US$) in 2011 in Latin America(developing only) to that in Low & middle income?
Provide a short and direct response. 0.09. What is the ratio of the Aid flow from UN agencies (US$) of 2012 in Latin America(developing only) to that in Low & middle income?
Keep it short and to the point. 0.09. What is the ratio of the Aid flow from UN agencies (US$) of 2009 in Latin America(developing only) to that in Middle income?
Offer a very short reply. 2. What is the ratio of the Aid flow from UN agencies (US$) of 2010 in Latin America(developing only) to that in Middle income?
Your answer should be compact. 1.5. What is the ratio of the Aid flow from UN agencies (US$) in 2011 in Latin America(developing only) to that in Middle income?
Offer a very short reply. 0.43. What is the ratio of the Aid flow from UN agencies (US$) in 2012 in Latin America(developing only) to that in Middle income?
Ensure brevity in your answer.  0.45. What is the ratio of the Aid flow from UN agencies (US$) of 2009 in Latin America(developing only) to that in Sub-Saharan Africa (all income levels)?
Your answer should be compact. 0.4. What is the ratio of the Aid flow from UN agencies (US$) in 2010 in Latin America(developing only) to that in Sub-Saharan Africa (all income levels)?
Keep it short and to the point. 0.42. What is the ratio of the Aid flow from UN agencies (US$) in 2011 in Latin America(developing only) to that in Sub-Saharan Africa (all income levels)?
Give a very brief answer. 0.37. What is the ratio of the Aid flow from UN agencies (US$) of 2012 in Latin America(developing only) to that in Sub-Saharan Africa (all income levels)?
Give a very brief answer. 0.41. What is the ratio of the Aid flow from UN agencies (US$) in 2009 in Latin America(developing only) to that in Sub-Saharan Africa (developing only)?
Offer a terse response. 0.4. What is the ratio of the Aid flow from UN agencies (US$) of 2010 in Latin America(developing only) to that in Sub-Saharan Africa (developing only)?
Provide a succinct answer. 0.42. What is the ratio of the Aid flow from UN agencies (US$) of 2011 in Latin America(developing only) to that in Sub-Saharan Africa (developing only)?
Make the answer very short. 0.37. What is the ratio of the Aid flow from UN agencies (US$) of 2012 in Latin America(developing only) to that in Sub-Saharan Africa (developing only)?
Give a very brief answer. 0.42. What is the ratio of the Aid flow from UN agencies (US$) of 2009 in Latin America(developing only) to that in World?
Ensure brevity in your answer.  0.1. What is the ratio of the Aid flow from UN agencies (US$) of 2010 in Latin America(developing only) to that in World?
Your response must be concise. 0.1. What is the ratio of the Aid flow from UN agencies (US$) in 2011 in Latin America(developing only) to that in World?
Your answer should be compact. 0.09. What is the ratio of the Aid flow from UN agencies (US$) of 2012 in Latin America(developing only) to that in World?
Give a very brief answer. 0.09. What is the ratio of the Aid flow from UN agencies (US$) in 2009 in Low & middle income to that in Middle income?
Make the answer very short. 21. What is the ratio of the Aid flow from UN agencies (US$) in 2010 in Low & middle income to that in Middle income?
Your answer should be compact. 14.61. What is the ratio of the Aid flow from UN agencies (US$) of 2011 in Low & middle income to that in Middle income?
Offer a terse response. 5.02. What is the ratio of the Aid flow from UN agencies (US$) of 2012 in Low & middle income to that in Middle income?
Ensure brevity in your answer.  4.76. What is the ratio of the Aid flow from UN agencies (US$) of 2009 in Low & middle income to that in Sub-Saharan Africa (all income levels)?
Offer a terse response. 4.22. What is the ratio of the Aid flow from UN agencies (US$) in 2010 in Low & middle income to that in Sub-Saharan Africa (all income levels)?
Make the answer very short. 4.08. What is the ratio of the Aid flow from UN agencies (US$) in 2011 in Low & middle income to that in Sub-Saharan Africa (all income levels)?
Provide a short and direct response. 4.25. What is the ratio of the Aid flow from UN agencies (US$) in 2012 in Low & middle income to that in Sub-Saharan Africa (all income levels)?
Provide a short and direct response. 4.38. What is the ratio of the Aid flow from UN agencies (US$) of 2009 in Low & middle income to that in Sub-Saharan Africa (developing only)?
Provide a short and direct response. 4.22. What is the ratio of the Aid flow from UN agencies (US$) in 2010 in Low & middle income to that in Sub-Saharan Africa (developing only)?
Ensure brevity in your answer.  4.08. What is the ratio of the Aid flow from UN agencies (US$) in 2011 in Low & middle income to that in Sub-Saharan Africa (developing only)?
Your response must be concise. 4.28. What is the ratio of the Aid flow from UN agencies (US$) in 2012 in Low & middle income to that in Sub-Saharan Africa (developing only)?
Provide a succinct answer. 4.41. What is the ratio of the Aid flow from UN agencies (US$) in 2009 in Low & middle income to that in World?
Your answer should be very brief. 1. What is the ratio of the Aid flow from UN agencies (US$) in 2010 in Low & middle income to that in World?
Offer a terse response. 1. What is the ratio of the Aid flow from UN agencies (US$) of 2012 in Low & middle income to that in World?
Keep it short and to the point. 1. What is the ratio of the Aid flow from UN agencies (US$) of 2009 in Middle income to that in Sub-Saharan Africa (all income levels)?
Make the answer very short. 0.2. What is the ratio of the Aid flow from UN agencies (US$) in 2010 in Middle income to that in Sub-Saharan Africa (all income levels)?
Your response must be concise. 0.28. What is the ratio of the Aid flow from UN agencies (US$) in 2011 in Middle income to that in Sub-Saharan Africa (all income levels)?
Offer a very short reply. 0.85. What is the ratio of the Aid flow from UN agencies (US$) of 2012 in Middle income to that in Sub-Saharan Africa (all income levels)?
Ensure brevity in your answer.  0.92. What is the ratio of the Aid flow from UN agencies (US$) of 2009 in Middle income to that in Sub-Saharan Africa (developing only)?
Your answer should be compact. 0.2. What is the ratio of the Aid flow from UN agencies (US$) in 2010 in Middle income to that in Sub-Saharan Africa (developing only)?
Make the answer very short. 0.28. What is the ratio of the Aid flow from UN agencies (US$) of 2011 in Middle income to that in Sub-Saharan Africa (developing only)?
Give a very brief answer. 0.85. What is the ratio of the Aid flow from UN agencies (US$) in 2012 in Middle income to that in Sub-Saharan Africa (developing only)?
Offer a terse response. 0.93. What is the ratio of the Aid flow from UN agencies (US$) in 2009 in Middle income to that in World?
Keep it short and to the point. 0.05. What is the ratio of the Aid flow from UN agencies (US$) in 2010 in Middle income to that in World?
Provide a succinct answer. 0.07. What is the ratio of the Aid flow from UN agencies (US$) of 2011 in Middle income to that in World?
Your answer should be compact. 0.2. What is the ratio of the Aid flow from UN agencies (US$) in 2012 in Middle income to that in World?
Keep it short and to the point. 0.21. What is the ratio of the Aid flow from UN agencies (US$) in 2009 in Sub-Saharan Africa (all income levels) to that in Sub-Saharan Africa (developing only)?
Offer a terse response. 1. What is the ratio of the Aid flow from UN agencies (US$) in 2011 in Sub-Saharan Africa (all income levels) to that in Sub-Saharan Africa (developing only)?
Provide a succinct answer. 1.01. What is the ratio of the Aid flow from UN agencies (US$) in 2009 in Sub-Saharan Africa (all income levels) to that in World?
Keep it short and to the point. 0.24. What is the ratio of the Aid flow from UN agencies (US$) of 2010 in Sub-Saharan Africa (all income levels) to that in World?
Ensure brevity in your answer.  0.25. What is the ratio of the Aid flow from UN agencies (US$) in 2011 in Sub-Saharan Africa (all income levels) to that in World?
Offer a very short reply. 0.23. What is the ratio of the Aid flow from UN agencies (US$) of 2012 in Sub-Saharan Africa (all income levels) to that in World?
Your response must be concise. 0.23. What is the ratio of the Aid flow from UN agencies (US$) of 2009 in Sub-Saharan Africa (developing only) to that in World?
Provide a succinct answer. 0.24. What is the ratio of the Aid flow from UN agencies (US$) in 2010 in Sub-Saharan Africa (developing only) to that in World?
Your answer should be compact. 0.25. What is the ratio of the Aid flow from UN agencies (US$) in 2011 in Sub-Saharan Africa (developing only) to that in World?
Offer a terse response. 0.23. What is the ratio of the Aid flow from UN agencies (US$) of 2012 in Sub-Saharan Africa (developing only) to that in World?
Your response must be concise. 0.23. What is the difference between the highest and the second highest Aid flow from UN agencies (US$) in 2009?
Your response must be concise. 0. What is the difference between the highest and the second highest Aid flow from UN agencies (US$) in 2010?
Your answer should be compact. 0. What is the difference between the highest and the second highest Aid flow from UN agencies (US$) in 2011?
Provide a short and direct response. 6.70e+05. What is the difference between the highest and the second highest Aid flow from UN agencies (US$) in 2012?
Offer a very short reply. 7.20e+05. What is the difference between the highest and the lowest Aid flow from UN agencies (US$) of 2009?
Make the answer very short. 4.16e+08. What is the difference between the highest and the lowest Aid flow from UN agencies (US$) of 2010?
Give a very brief answer. 3.41e+08. What is the difference between the highest and the lowest Aid flow from UN agencies (US$) in 2011?
Give a very brief answer. 4.13e+08. What is the difference between the highest and the lowest Aid flow from UN agencies (US$) in 2012?
Keep it short and to the point. 3.59e+08. 